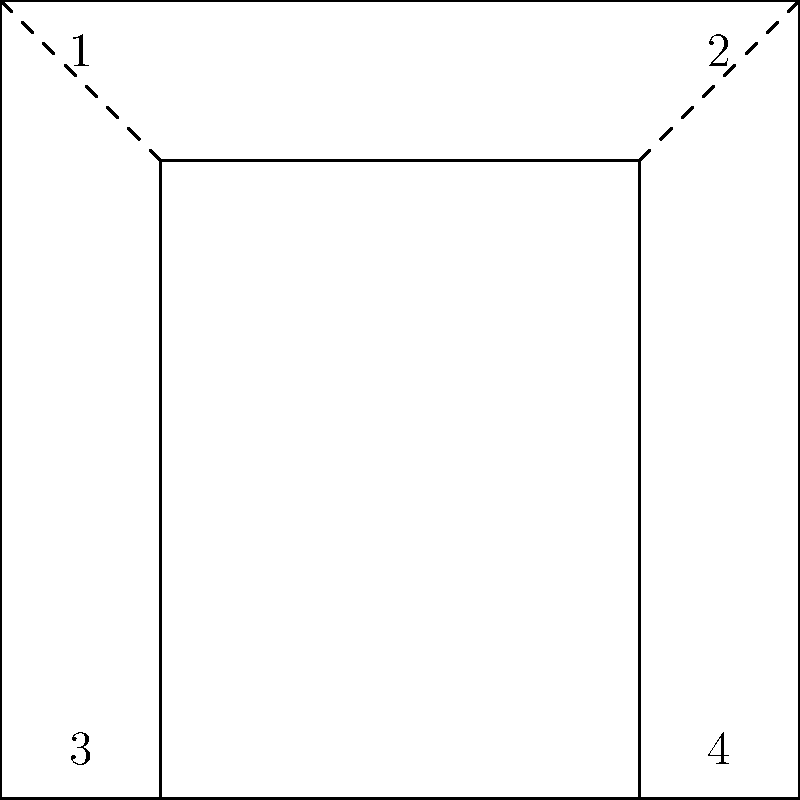Look at this simplified diagram of two skyscrapers in NYC. Which angle is congruent to angle 1? To find the congruent angle to angle 1, let's follow these steps:

1. Recognize that the diagram shows two rectangles, representing simplified skyscraper silhouettes.

2. In a rectangle, opposite angles are always congruent.

3. Angle 1 is located in the top-left corner of the larger rectangle.

4. The angle opposite to angle 1 would be in the bottom-right corner of the larger rectangle, which is angle 4.

5. The dashed lines indicate that the smaller rectangle is similar to the larger one, meaning their angles are corresponding and congruent.

6. Therefore, the angle in the smaller rectangle that corresponds to angle 1 in the larger rectangle is also located in the top-left corner, which is angle 3.

7. Since angle 3 corresponds to angle 1 in similar rectangles, they are congruent.

Thus, angle 3 is congruent to angle 1.
Answer: 3 